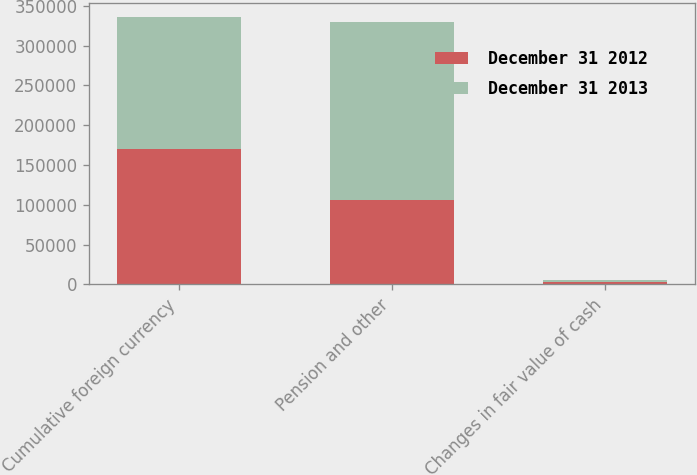<chart> <loc_0><loc_0><loc_500><loc_500><stacked_bar_chart><ecel><fcel>Cumulative foreign currency<fcel>Pension and other<fcel>Changes in fair value of cash<nl><fcel>December 31 2012<fcel>170608<fcel>105380<fcel>2495<nl><fcel>December 31 2013<fcel>165872<fcel>223887<fcel>3109<nl></chart> 